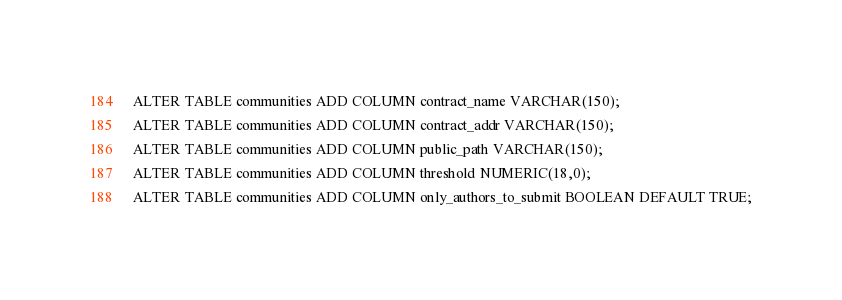<code> <loc_0><loc_0><loc_500><loc_500><_SQL_>ALTER TABLE communities ADD COLUMN contract_name VARCHAR(150);
ALTER TABLE communities ADD COLUMN contract_addr VARCHAR(150);
ALTER TABLE communities ADD COLUMN public_path VARCHAR(150);
ALTER TABLE communities ADD COLUMN threshold NUMERIC(18,0);
ALTER TABLE communities ADD COLUMN only_authors_to_submit BOOLEAN DEFAULT TRUE;
</code> 